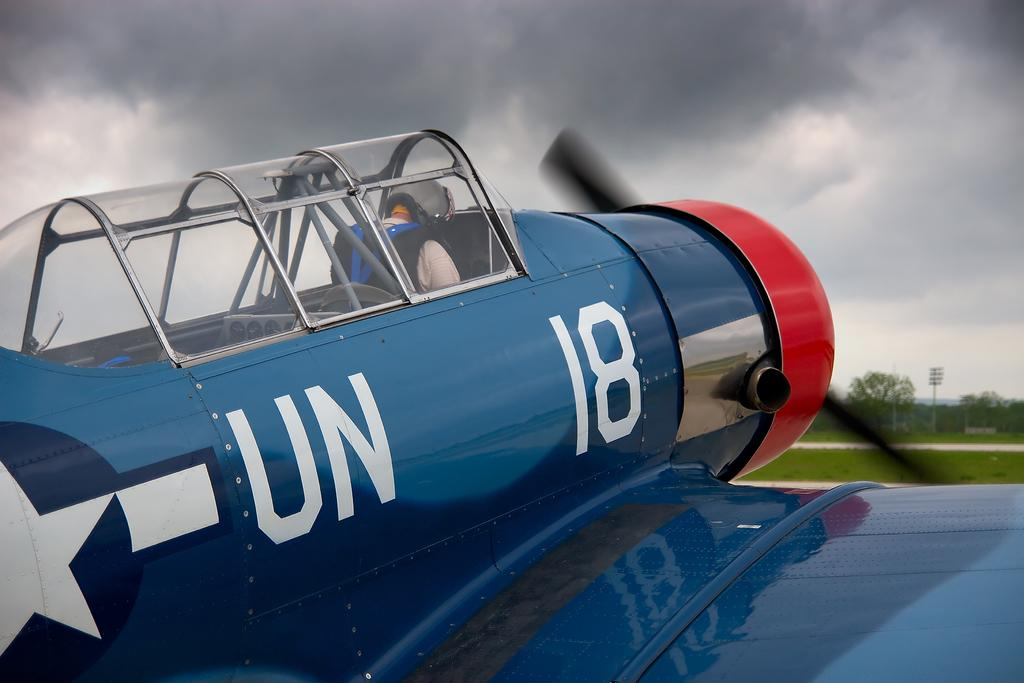Provide a one-sentence caption for the provided image. a pilot plane in blue from the UN and number 18. 